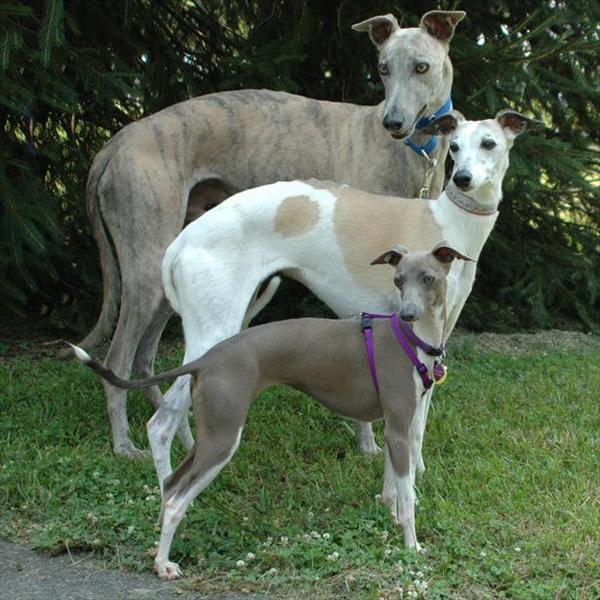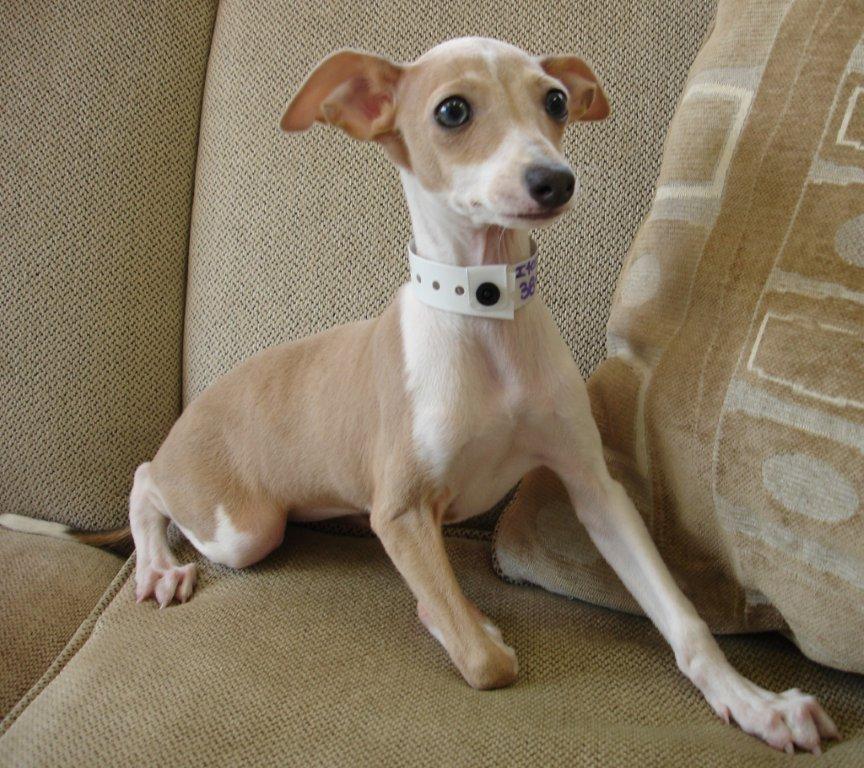The first image is the image on the left, the second image is the image on the right. For the images displayed, is the sentence "At least one of the dogs is outside on the grass." factually correct? Answer yes or no. Yes. The first image is the image on the left, the second image is the image on the right. Assess this claim about the two images: "An image shows a standing dog with its white tail tip curled under and between its legs.". Correct or not? Answer yes or no. Yes. 